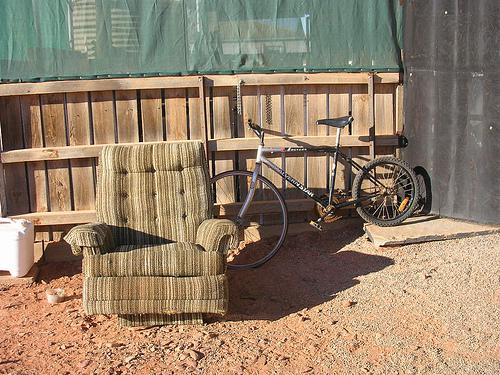Question: what is odd about the bicycle?
Choices:
A. It has three wheels.
B. One wheel is much larger.
C. It has two seats.
D. It has no basket.
Answer with the letter. Answer: B Question: where could this be?
Choices:
A. A zoo.
B. A barnyard.
C. A city.
D. A church.
Answer with the letter. Answer: B 